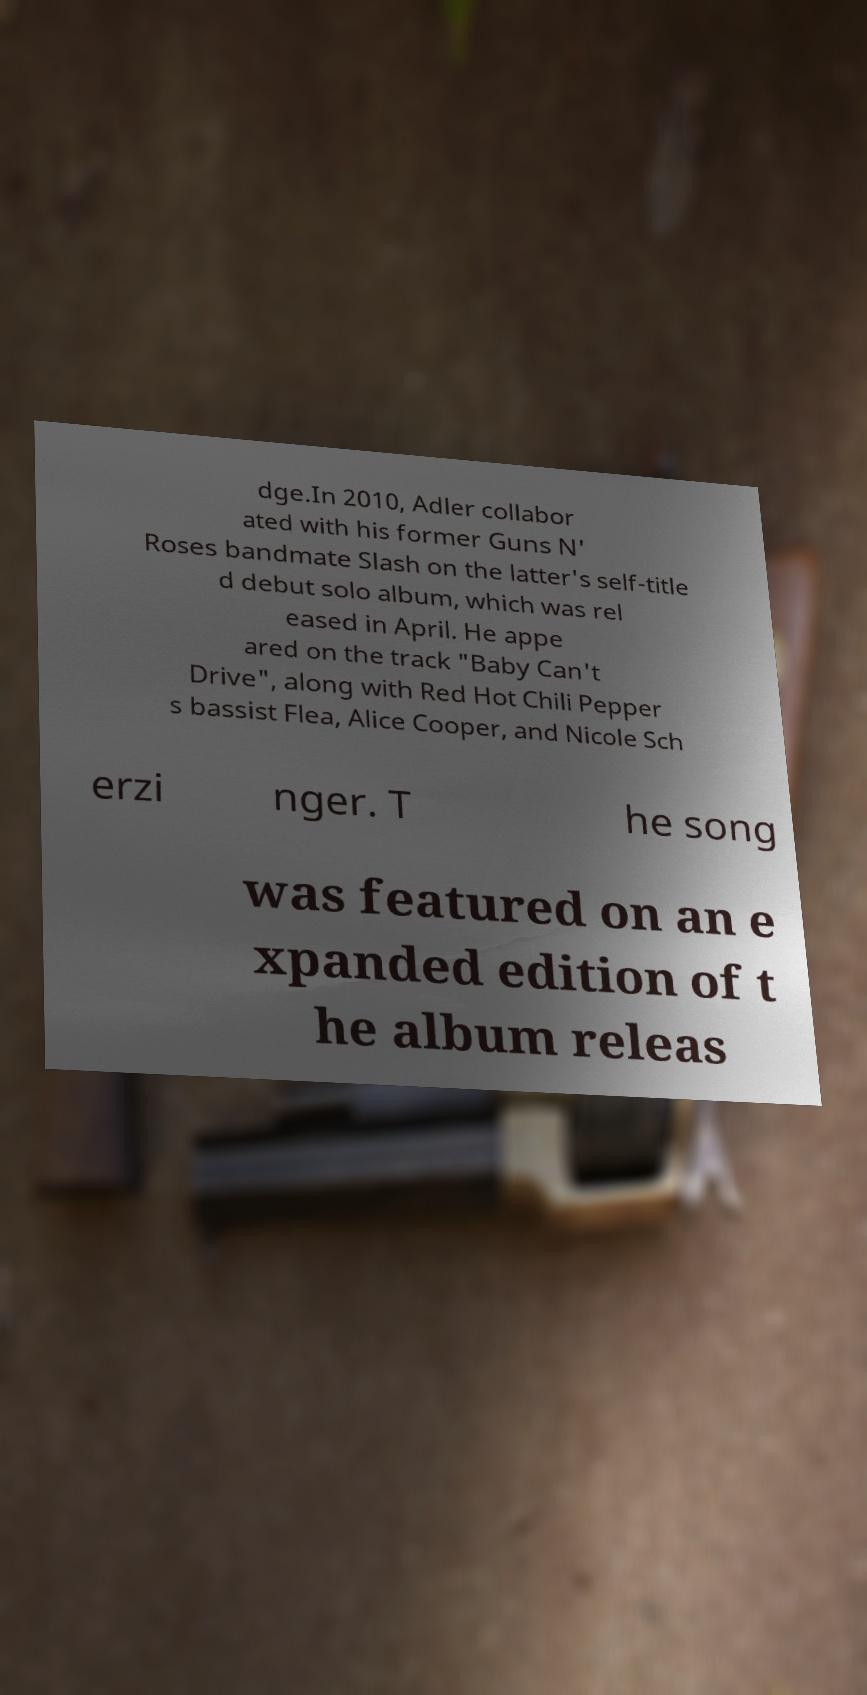Please read and relay the text visible in this image. What does it say? dge.In 2010, Adler collabor ated with his former Guns N' Roses bandmate Slash on the latter's self-title d debut solo album, which was rel eased in April. He appe ared on the track "Baby Can't Drive", along with Red Hot Chili Pepper s bassist Flea, Alice Cooper, and Nicole Sch erzi nger. T he song was featured on an e xpanded edition of t he album releas 